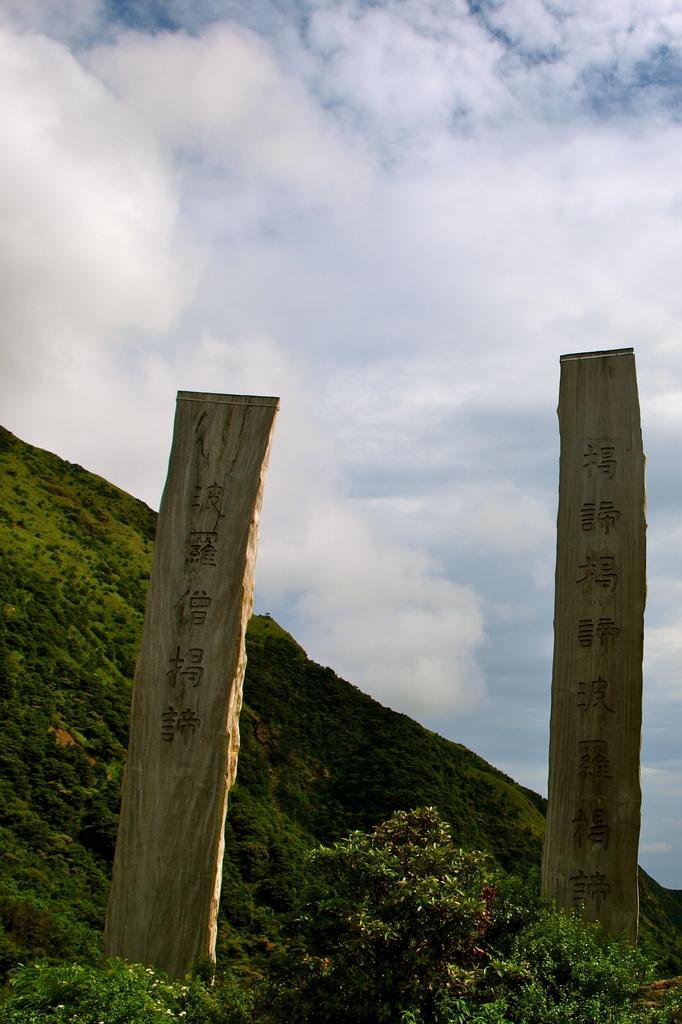In one or two sentences, can you explain what this image depicts? In this image, we can see memorial stones contains some symbols. There is a tree at the bottom of the image. There is a hill in the bottom left of the image. There is a sky at the top of the image. 